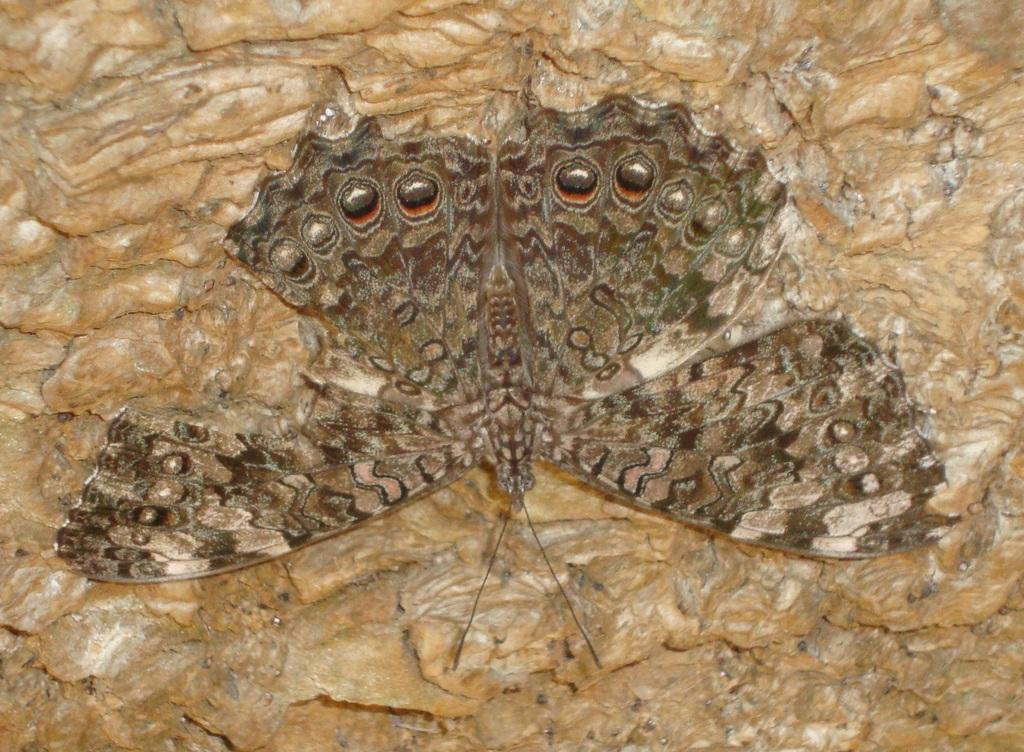What is the main subject of the image? The main subject of the image is a butterfly. Where is the butterfly located in the image? The butterfly is on a wooden surface. What type of fruit is the giraffe eating in the image? There is no giraffe or fruit present in the image; it features a butterfly on a wooden surface. What scent can be detected from the butterfly in the image? Butterflies do not have a scent that can be detected in an image. 